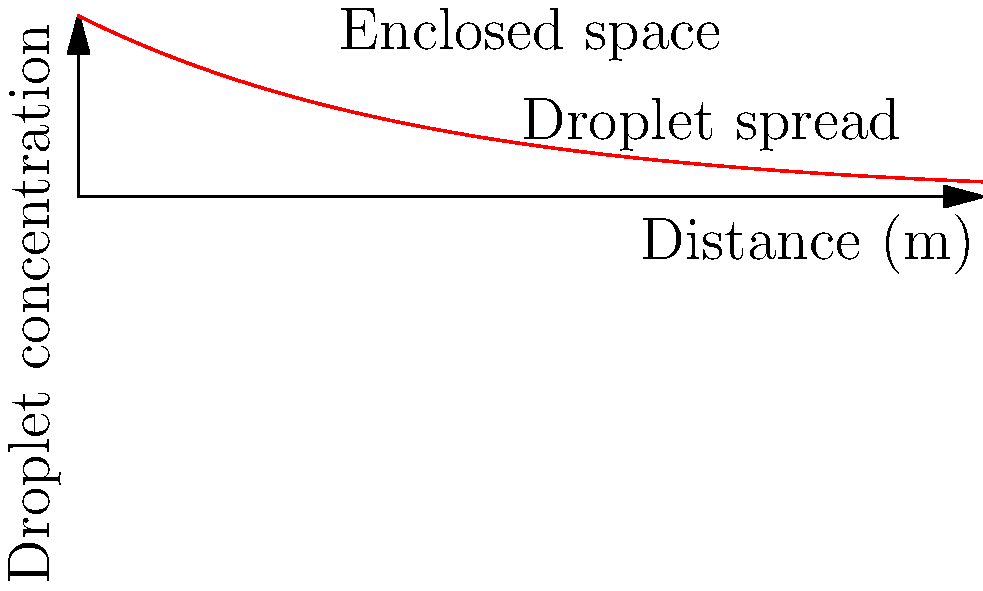In an enclosed space, such as a hospital room or counseling office, the concentration of respiratory droplets decreases exponentially with distance from the source. If the concentration at the source is 100%, and it decreases by half every 2 meters, what percentage of the initial concentration would you expect at a distance of 4 meters from the source? To solve this problem, we need to follow these steps:

1. Understand the exponential decay model:
   The concentration $C$ at distance $x$ is given by $C(x) = C_0 \cdot 2^{-x/d}$,
   where $C_0$ is the initial concentration and $d$ is the distance at which the concentration halves.

2. Identify the given information:
   - Initial concentration $C_0 = 100\%$
   - Half-distance $d = 2$ meters
   - Distance of interest $x = 4$ meters

3. Plug these values into the equation:
   $C(4) = 100\% \cdot 2^{-4/2}$

4. Simplify the exponent:
   $C(4) = 100\% \cdot 2^{-2}$

5. Calculate the result:
   $C(4) = 100\% \cdot \frac{1}{4} = 25\%$

Therefore, at a distance of 4 meters, the concentration would be 25% of the initial concentration.
Answer: 25% 